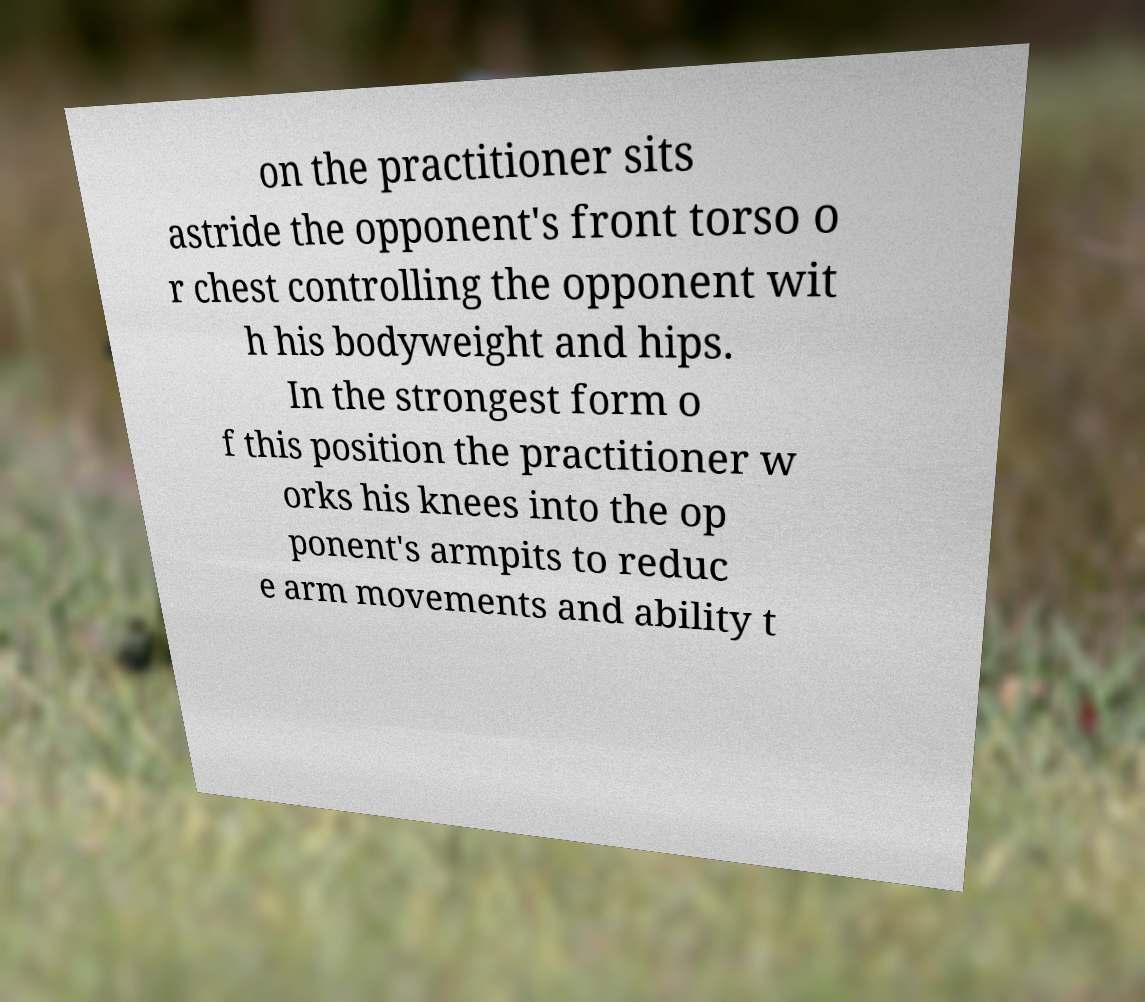I need the written content from this picture converted into text. Can you do that? on the practitioner sits astride the opponent's front torso o r chest controlling the opponent wit h his bodyweight and hips. In the strongest form o f this position the practitioner w orks his knees into the op ponent's armpits to reduc e arm movements and ability t 